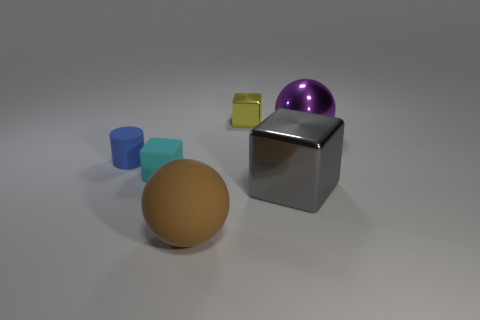Add 1 large matte blocks. How many objects exist? 7 Subtract all cylinders. How many objects are left? 5 Add 1 yellow things. How many yellow things are left? 2 Add 6 small blue objects. How many small blue objects exist? 7 Subtract 0 gray balls. How many objects are left? 6 Subtract all brown rubber cylinders. Subtract all big matte balls. How many objects are left? 5 